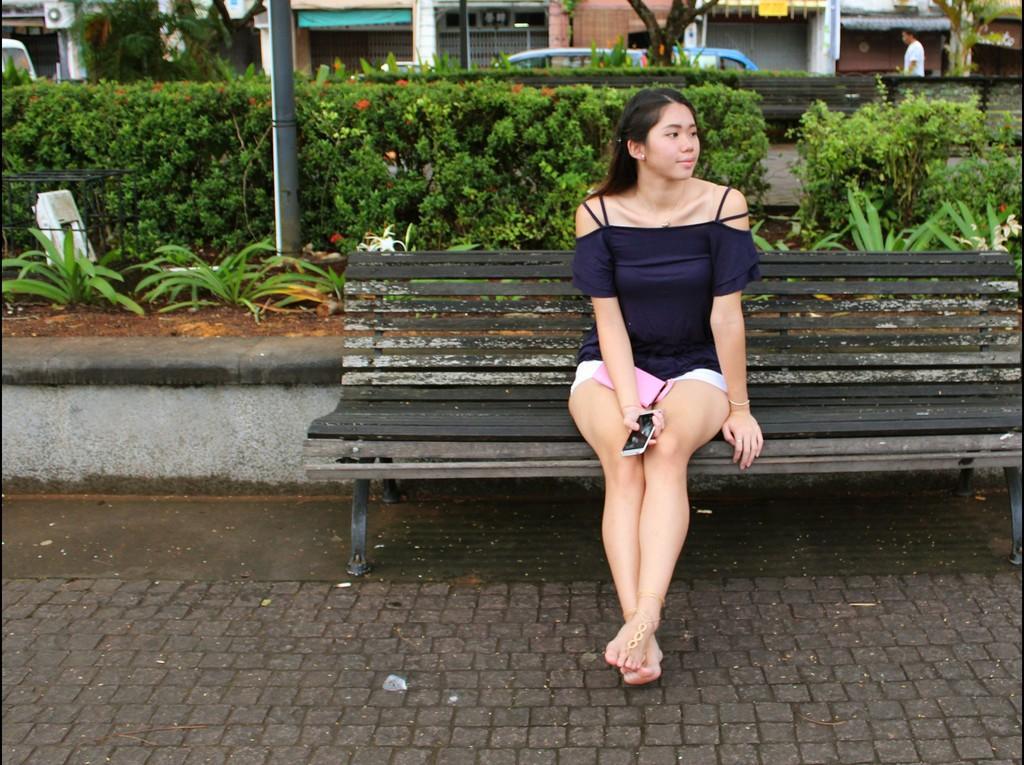In one or two sentences, can you explain what this image depicts? There is a woman sitting on a wooden table. In the background we can see plants, a car and a man walking and he is on the top right side. 